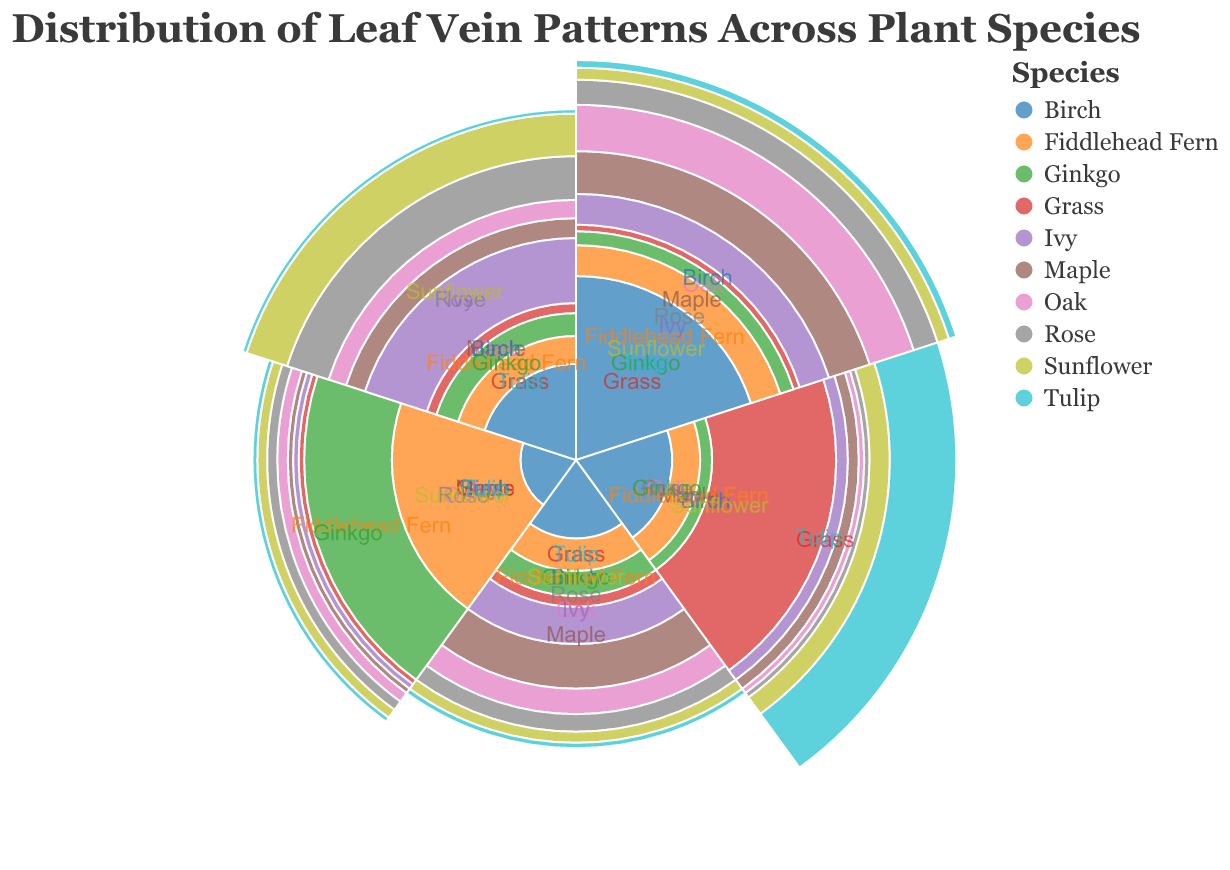What's the title of the chart? The title of the chart is clearly written at the top.
Answer: Distribution of Leaf Vein Patterns Across Plant Species Which species has the highest value for Parallel veins? Look for the species with the largest radius in the section labeled "Parallel."
Answer: Grass Which species has the smallest value for Reticulate veins? Check the sections labeled "Reticulate" and find the species with the smallest radius.
Answer: Grass What is the total value of Parallel veins across all species? Add up the values of Parallel veins for all species: 10+5+15+80+10+5+5+10+20+75.
Answer: 235 Compare the Pinnate values of Rose and Sunflower. Which is higher? Examine the distances from the center in the Pinnate category for both Rose and Sunflower.
Answer: Sunflower How do the Dichotomous veins in Ginkgo and Fiddlehead Fern compare? Check and compare the distances for Dichotomous in both Ginkgo and Fiddlehead Fern.
Answer: Ginkgo is higher What is the average value of Palmate veins across all species? Sum the values of Palmate veins for all species, then divide by the number of species: (30+20+10+5+10+10+15+20+10+5) / 10.
Answer: 13.5 Which vein pattern has the most consistent value across the species? Look for the vein pattern where radii have the least variation across different species.
Answer: Dichotomous Which vein pattern is most common in the Rose plant? Look at which section has the longest radius for the Rose plant.
Answer: Pinnate How do Maple's Palmate values compare to its Pinnate values? Compare the radii for Palmate and Pinnate categories for the Maple species.
Answer: Palmate is higher 